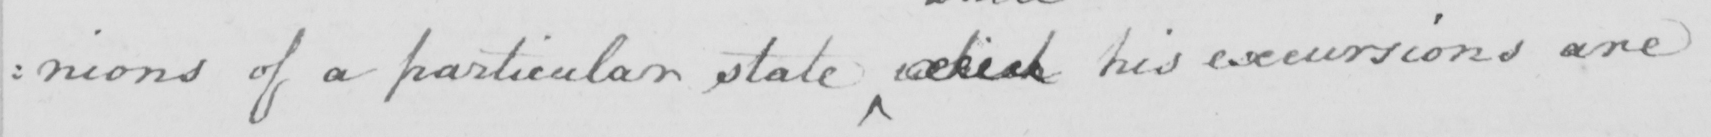What text is written in this handwritten line? :nions of a particular state which his excursions are 